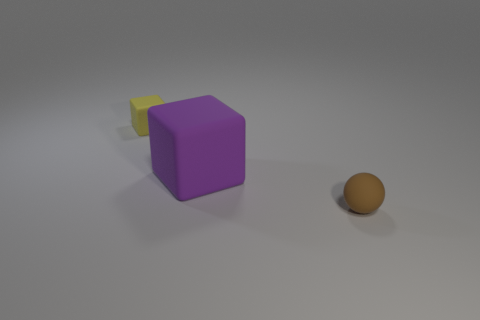Are there any yellow blocks of the same size as the brown sphere?
Provide a succinct answer. Yes. Is the number of purple rubber blocks behind the yellow cube the same as the number of large purple rubber blocks in front of the small matte sphere?
Your response must be concise. Yes. Do the thing that is in front of the large matte thing and the matte object that is behind the large purple thing have the same size?
Your answer should be compact. Yes. How many small rubber blocks are the same color as the small sphere?
Your answer should be compact. 0. Is the number of yellow matte things that are left of the brown object greater than the number of large cyan balls?
Your response must be concise. Yes. Do the big purple object and the small yellow thing have the same shape?
Offer a terse response. Yes. What number of other big things have the same material as the large object?
Offer a very short reply. 0. There is another matte thing that is the same shape as the tiny yellow rubber thing; what size is it?
Your answer should be very brief. Large. Do the yellow object and the purple matte object have the same size?
Offer a terse response. No. There is a small object that is in front of the small rubber object that is behind the big matte object on the right side of the tiny yellow matte object; what shape is it?
Your answer should be compact. Sphere. 